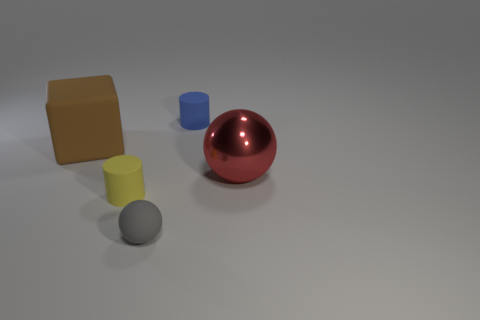Add 1 tiny cylinders. How many objects exist? 6 Add 1 big things. How many big things exist? 3 Subtract 1 gray balls. How many objects are left? 4 Subtract all blocks. How many objects are left? 4 Subtract all blue balls. Subtract all blue cylinders. How many balls are left? 2 Subtract all green cylinders. How many gray blocks are left? 0 Subtract all red objects. Subtract all purple rubber things. How many objects are left? 4 Add 2 blue matte objects. How many blue matte objects are left? 3 